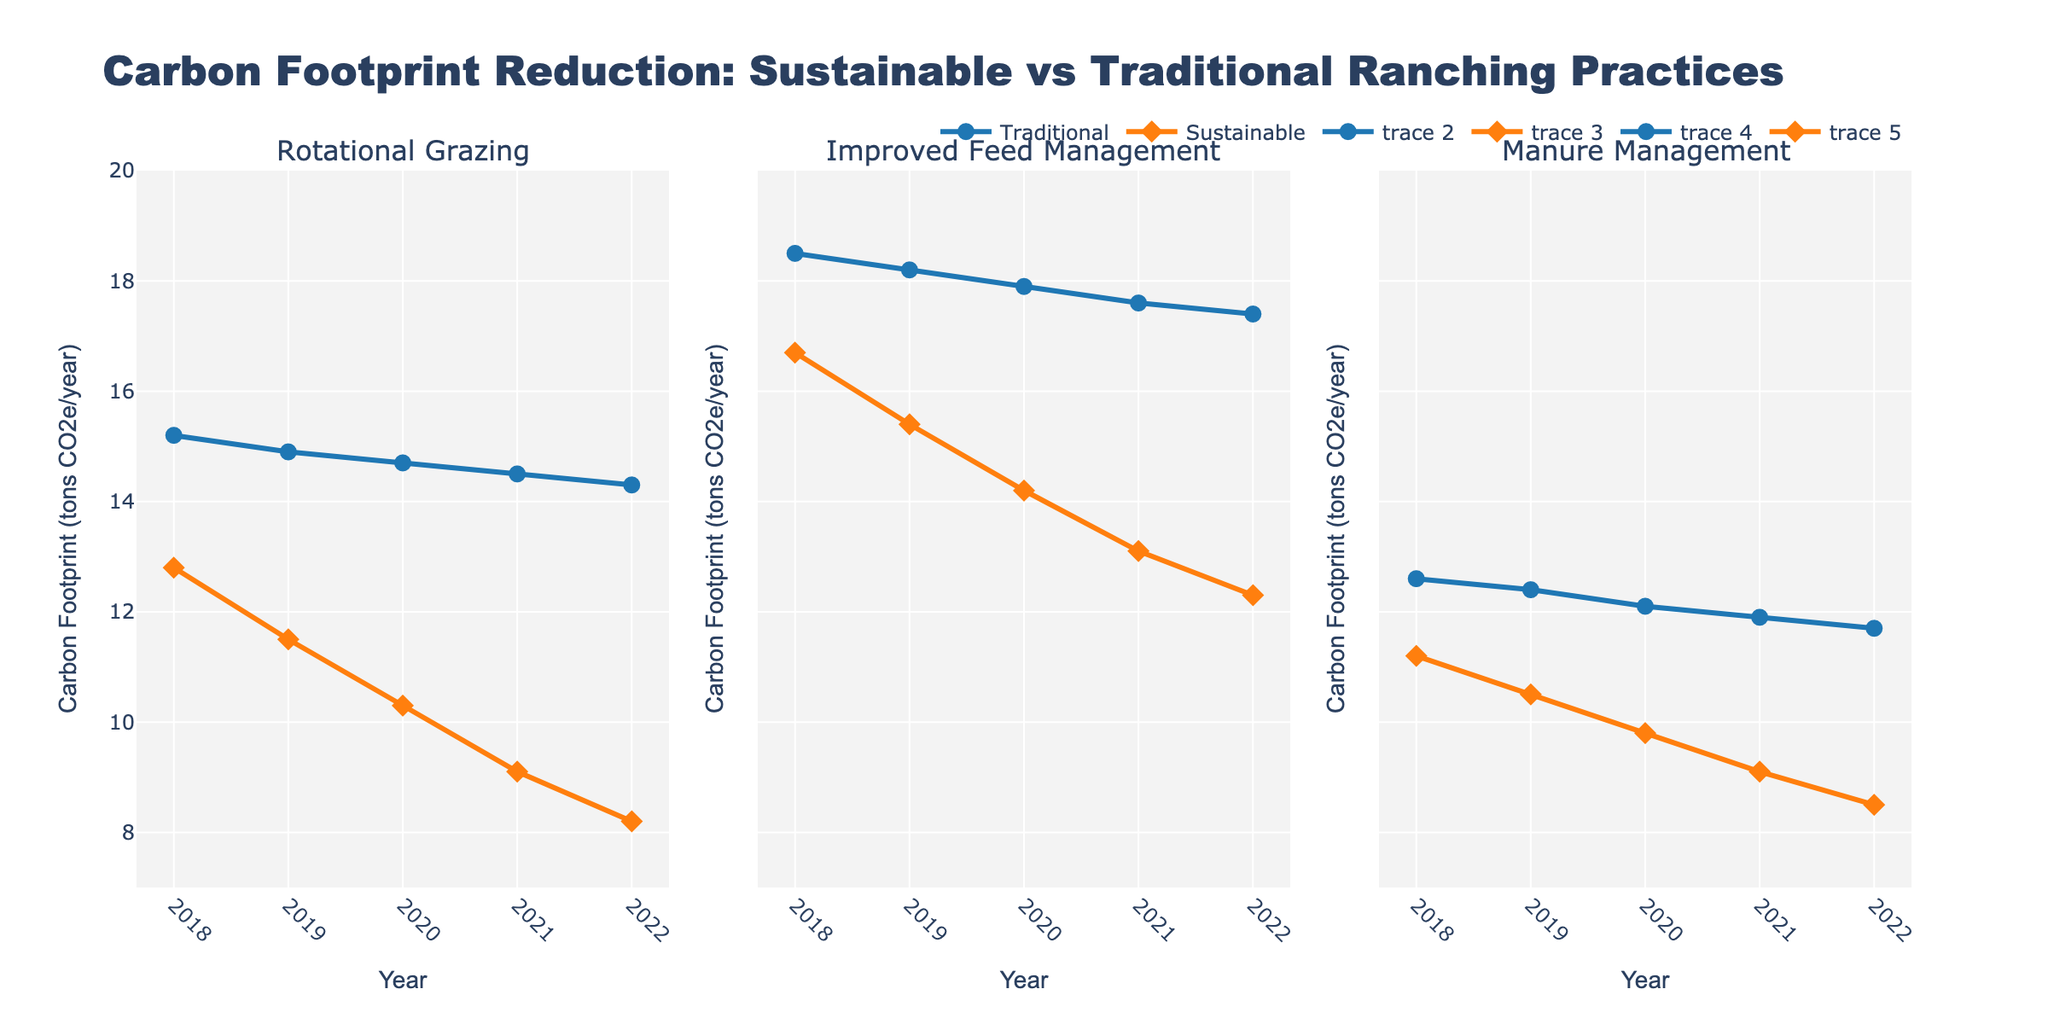Which state has the highest heart donation rate? By comparing the heart donation rates across states in the figure, we see that California has the highest rate at 12.5%.
Answer: California Between Texas and Florida, which state has a higher kidney donation rate? By looking at the kidney donation rates for Texas (32.1%) and Florida (31.5%) in the figure, Texas has a higher rate.
Answer: Texas What is the average liver donation rate for New York, Pennsylvania, and Illinois? The liver donation rates are: New York (17.9%), Pennsylvania (18.2%), and Illinois (15.6%). The average is calculated by summing these rates and dividing by 3. (17.9 + 18.2 + 15.6) / 3 = 51.7 / 3 = 17.23
Answer: 17.23 How much higher is Michigan's lung donation rate compared to Ohio's? Michigan's lung donation rate is 7.3%, and Ohio's is 7.0%. The difference between these rates is 7.3% - 7.0% = 0.3%.
Answer: 0.3% Which organ type shows the highest donation rate in Pennsylvania? By examining Pennsylvania's data for each organ type, we find: Heart (11.9%), Kidney (34.5%), Liver (18.2%), and Lung (8.5%). The highest rate is for Kidney at 34.5%.
Answer: Kidney What is the total donation rate for lung donations across all states? Adding the lung donation rates for all states: 8.9 + 7.6 + 8.3 + 7.8 + 7.2 + 8.5 + 7.0 + 6.8 + 6.9 + 7.3 = 76.3%
Answer: 76.3% Which state has the lowest liver donation rate? By comparing the liver donation rates in the figure, Georgia has the lowest rate at 14.5%.
Answer: Georgia How does Georgia's kidney donation rate compare with Ohio's? Georgia's kidney donation rate is 28.7%, and Ohio's is 29.8%. Thus, Georgia's kidney donation rate is lower than Ohio's.
Answer: Lower Identify the organ type with the highest variation in donation rates across states. By visually comparing the length of bars for each organ type, the kidney donation rates show the greatest variation, ranging from 28.7% to 35.2%.
Answer: Kidney 